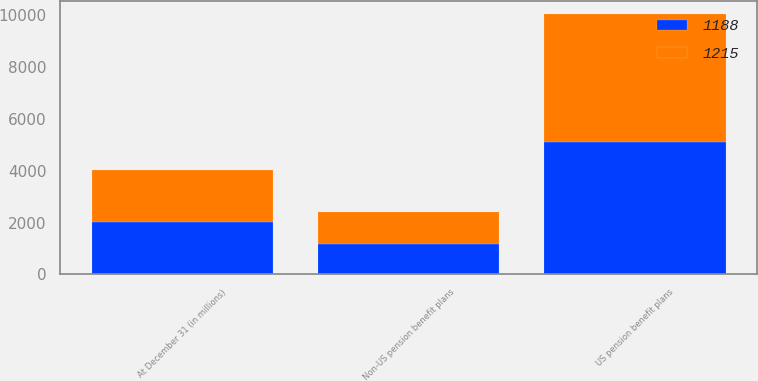Convert chart. <chart><loc_0><loc_0><loc_500><loc_500><stacked_bar_chart><ecel><fcel>At December 31 (in millions)<fcel>US pension benefit plans<fcel>Non-US pension benefit plans<nl><fcel>1188<fcel>2017<fcel>5091<fcel>1188<nl><fcel>1215<fcel>2016<fcel>4948<fcel>1215<nl></chart> 